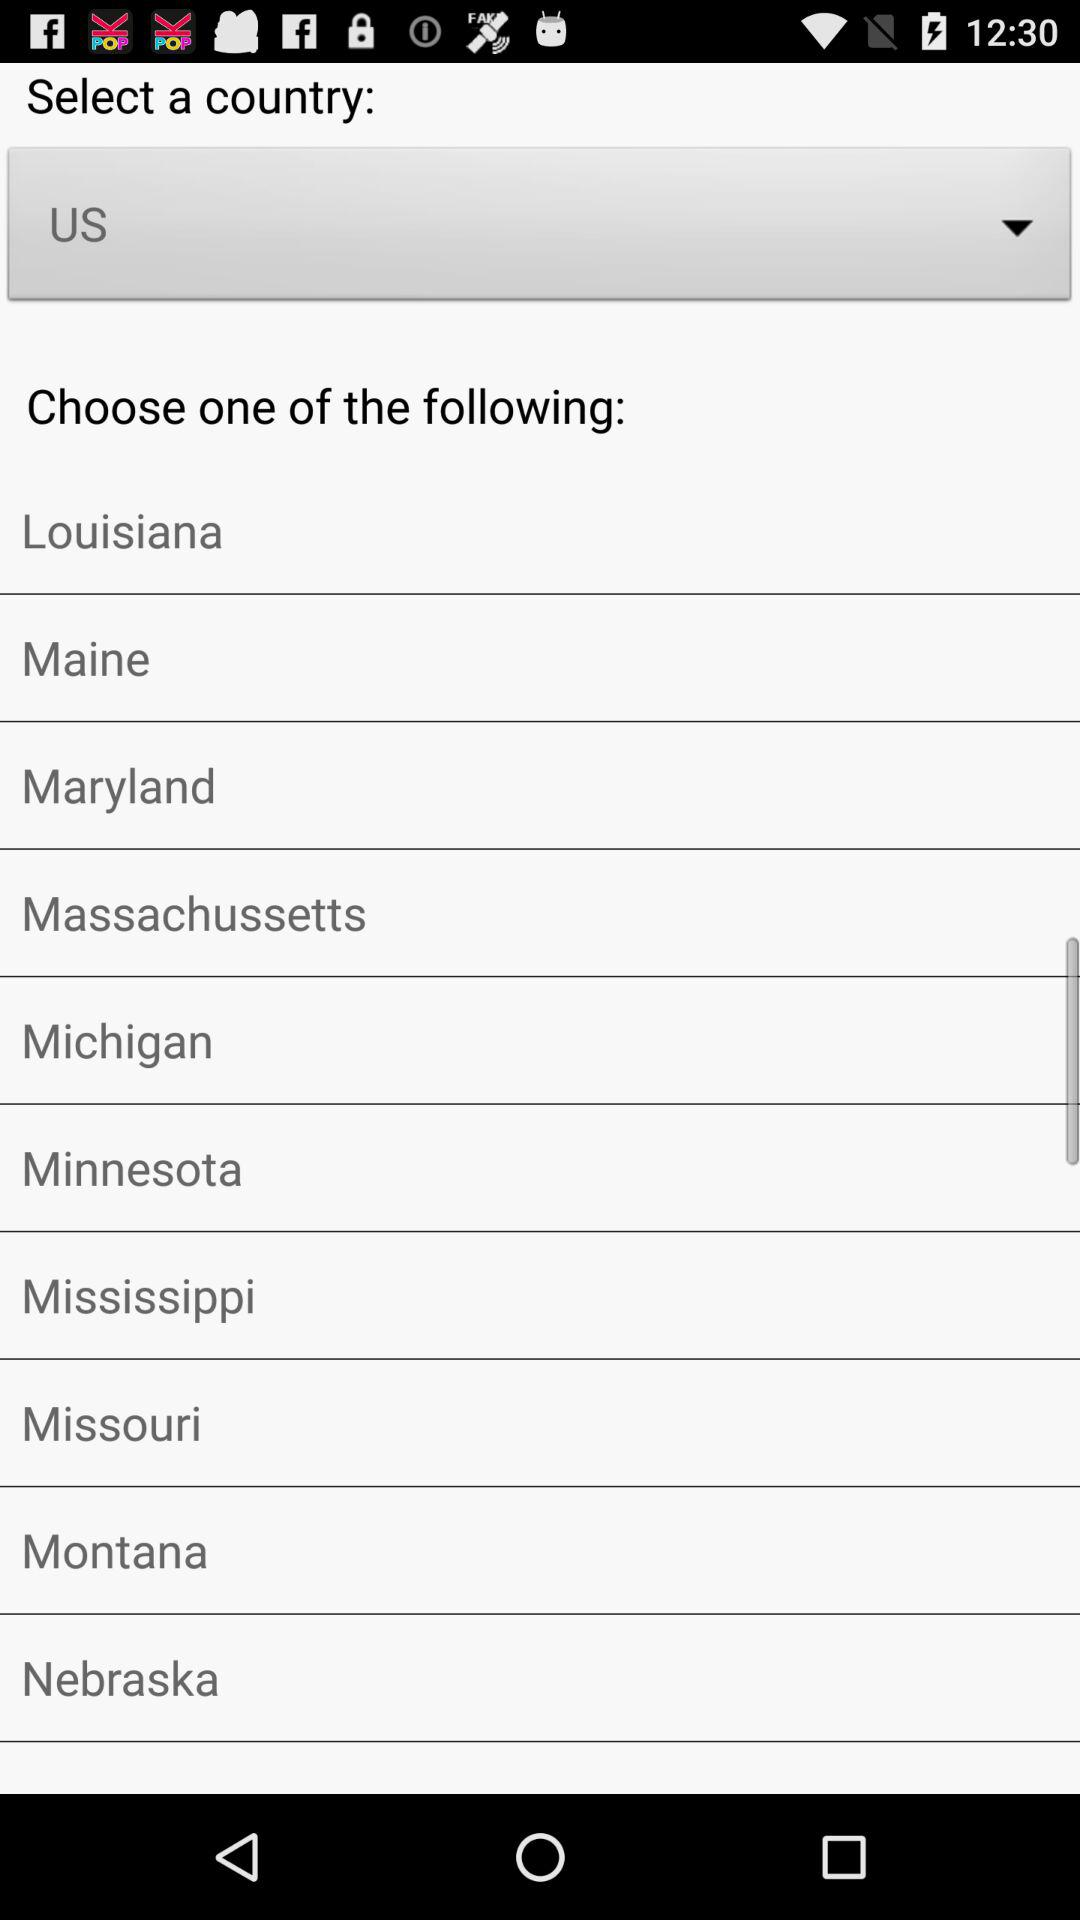What country has been selected? The selected country is "US". 